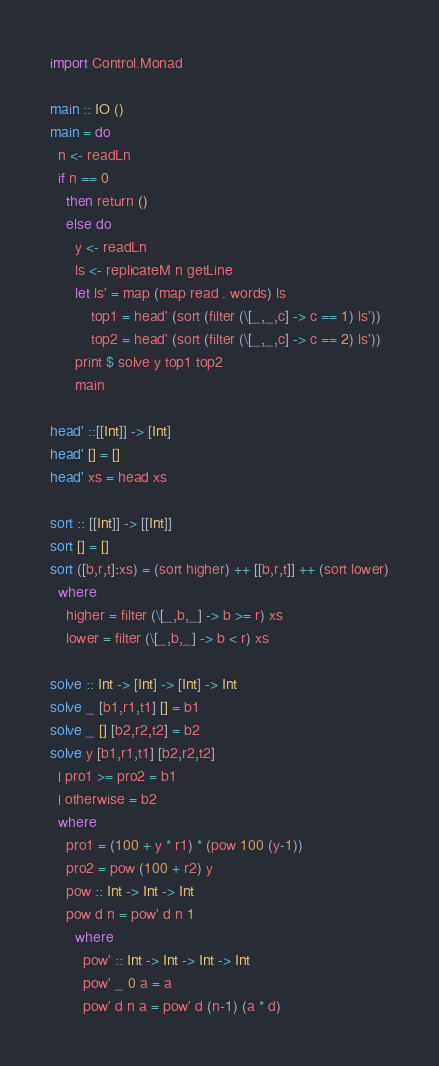Convert code to text. <code><loc_0><loc_0><loc_500><loc_500><_Haskell_>import Control.Monad

main :: IO ()
main = do
  n <- readLn
  if n == 0
    then return ()
    else do
      y <- readLn
      ls <- replicateM n getLine
      let ls' = map (map read . words) ls
          top1 = head' (sort (filter (\[_,_,c] -> c == 1) ls'))
          top2 = head' (sort (filter (\[_,_,c] -> c == 2) ls'))
      print $ solve y top1 top2
      main

head' ::[[Int]] -> [Int]
head' [] = []
head' xs = head xs

sort :: [[Int]] -> [[Int]]
sort [] = []
sort ([b,r,t]:xs) = (sort higher) ++ [[b,r,t]] ++ (sort lower)
  where
    higher = filter (\[_,b,_] -> b >= r) xs
    lower = filter (\[_,b,_] -> b < r) xs

solve :: Int -> [Int] -> [Int] -> Int
solve _ [b1,r1,t1] [] = b1
solve _ [] [b2,r2,t2] = b2
solve y [b1,r1,t1] [b2,r2,t2]
  | pro1 >= pro2 = b1
  | otherwise = b2
  where
    pro1 = (100 + y * r1) * (pow 100 (y-1))
    pro2 = pow (100 + r2) y
    pow :: Int -> Int -> Int
    pow d n = pow' d n 1
      where
        pow' :: Int -> Int -> Int -> Int
        pow' _ 0 a = a
        pow' d n a = pow' d (n-1) (a * d)</code> 